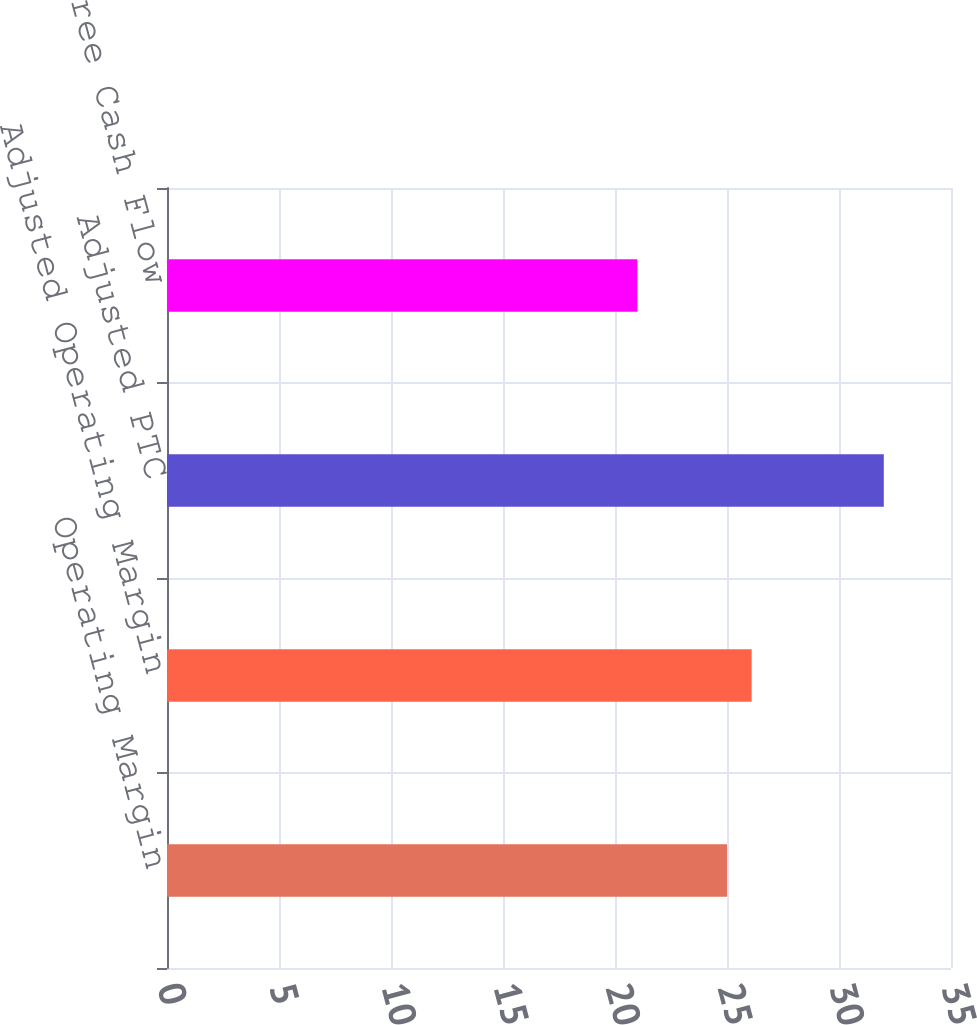<chart> <loc_0><loc_0><loc_500><loc_500><bar_chart><fcel>Operating Margin<fcel>Adjusted Operating Margin<fcel>Adjusted PTC<fcel>Proportional Free Cash Flow<nl><fcel>25<fcel>26.1<fcel>32<fcel>21<nl></chart> 